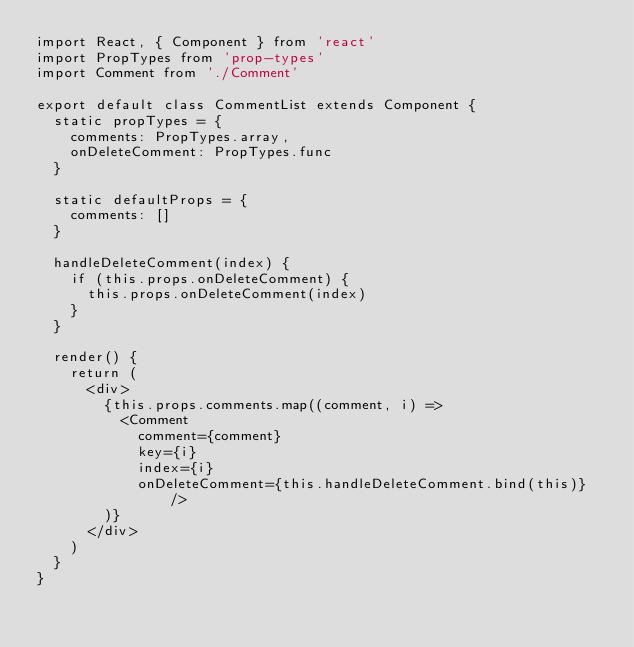Convert code to text. <code><loc_0><loc_0><loc_500><loc_500><_JavaScript_>import React, { Component } from 'react'
import PropTypes from 'prop-types'
import Comment from './Comment'

export default class CommentList extends Component {
  static propTypes = {
    comments: PropTypes.array,
    onDeleteComment: PropTypes.func
  }

  static defaultProps = {
    comments: []
  }

  handleDeleteComment(index) {
    if (this.props.onDeleteComment) {
      this.props.onDeleteComment(index)
    }
  }

  render() {
    return (
      <div>
        {this.props.comments.map((comment, i) =>
          <Comment
            comment={comment}
            key={i}
            index={i}
            onDeleteComment={this.handleDeleteComment.bind(this)} />
        )}
      </div>
    )
  }
}</code> 